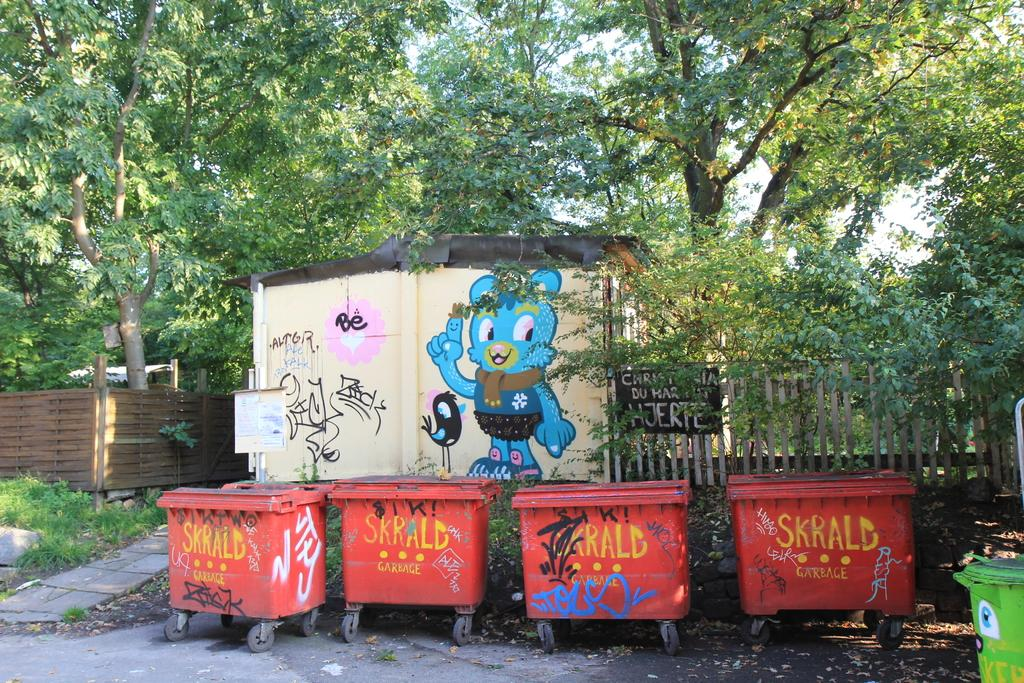<image>
Present a compact description of the photo's key features. Four red Skrald Garbage containers sitting in front of a wood fence 